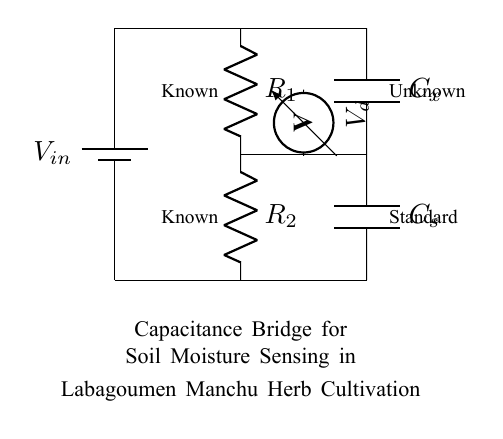What is the input voltage of the circuit? The input voltage is indicated as V_in on the battery symbol at the top left of the circuit diagram.
Answer: V_in What components are present in the circuit? The circuit includes a battery, two resistors labeled R_1 and R_2, two capacitors labeled C_x and C_s, and a voltmeter. This can be identified by looking at the labels and symbols in the circuit diagram.
Answer: Battery, resistors, capacitors, voltmeter What does the voltmeter measure in this circuit? The voltmeter, labeled as V_d, measures the voltage difference across the point where it is connected. It's positioned between the two capacitors, indicating it measures the voltage related to the unknown capacitance.
Answer: Voltage difference How many capacitors are used in the circuit? The circuit features two capacitors: C_x (the unknown capacitor) and C_s (the standard capacitor). This can be confirmed by counting the capacitor symbols in the diagram.
Answer: Two What is the purpose of the resistors in this circuit? The resistors R_1 and R_2 are used to balance the capacitance bridge. Their values help in adjusting the bridge for accurate measurement of the unknown capacitance by creating a balanced condition where the voltage across the voltmeter is zero.
Answer: Balance capacitance bridge What is the relationship between the known and unknown components in the circuit? The relationship is established through the balance of the capacitance bridge, where the known capacitance (C_s) and resistance (R_2) help determine the amount of unknown capacitance (C_x) by achieving a state where the voltmeter reads zero voltage, indicating equilibrium.
Answer: Relation via balance equation 